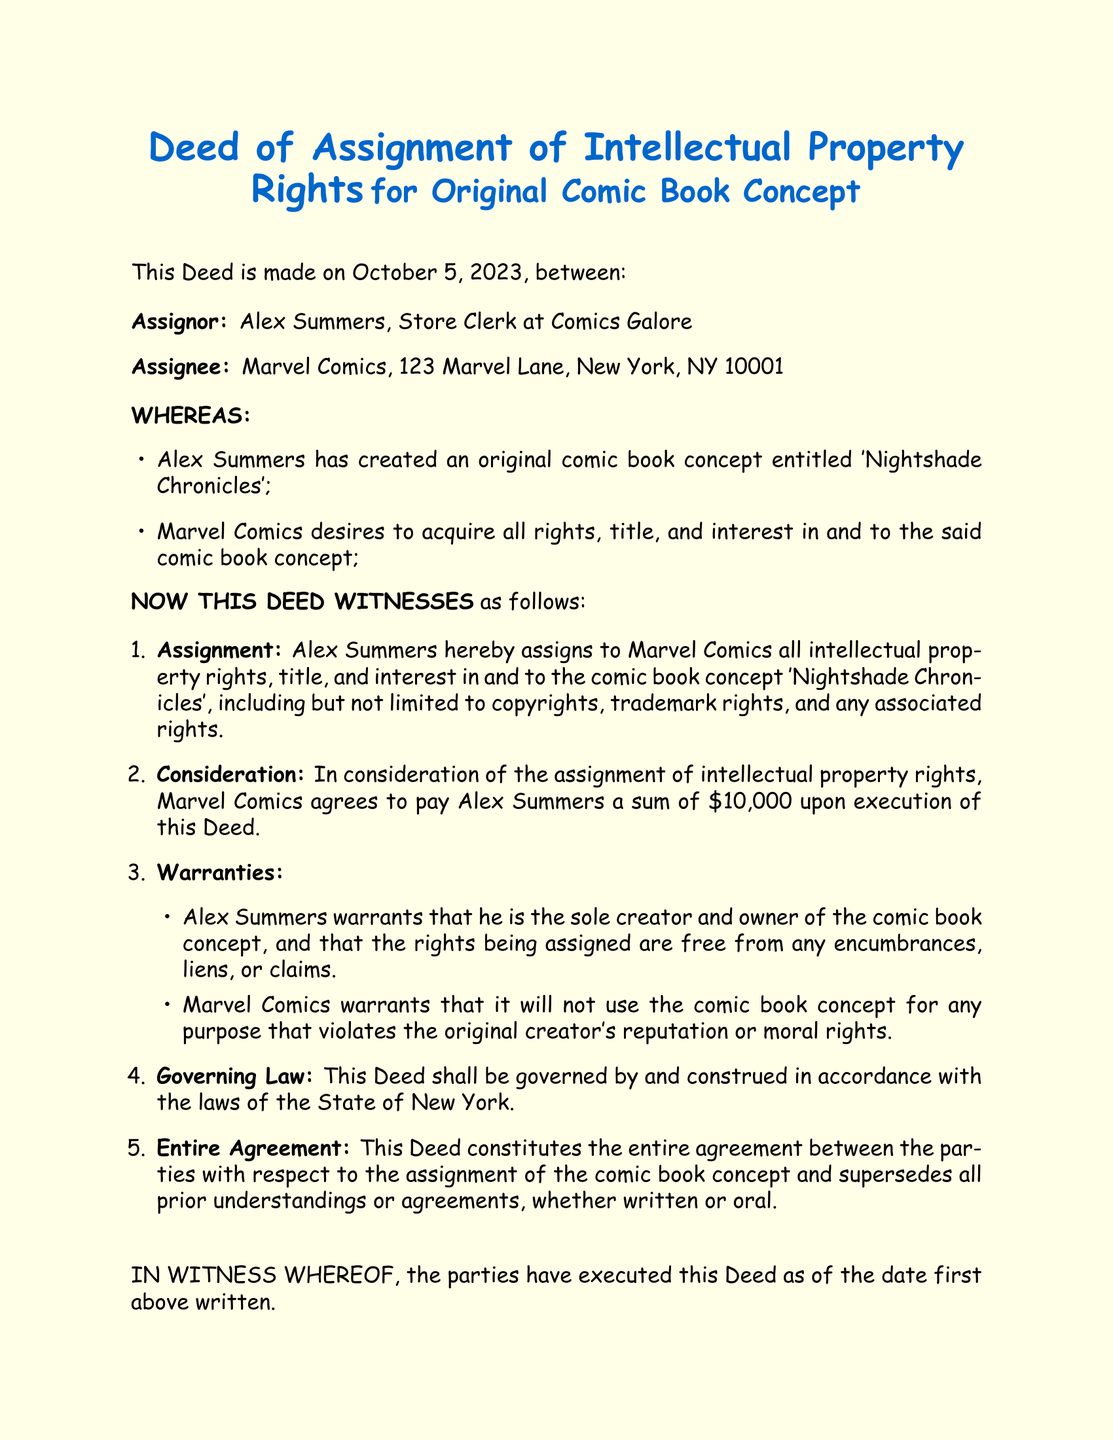What is the name of the original comic book concept? The document states that the original comic book concept is titled 'Nightshade Chronicles'.
Answer: 'Nightshade Chronicles' Who is the Assignor in the deed? The Assignor is identified as Alex Summers, Store Clerk at Comics Galore.
Answer: Alex Summers What is the amount agreed upon as consideration for the assignment? The consideration amount specified in the document is $10,000.
Answer: $10,000 What date was the deed executed? The deed was executed on October 5, 2023.
Answer: October 5, 2023 What warranties does Alex Summers provide? The warranties include that Alex Summers is the sole creator and owner of the comic book concept and that the rights are free from any encumbrances.
Answer: Sole creator and owner; free from encumbrances Under which state law is the deed governed? The deed specifies that it is governed by the laws of the State of New York.
Answer: State of New York What type of rights is assigned to Marvel Comics? The deed indicates that all intellectual property rights, title, and interest in the comic book concept are assigned.
Answer: Intellectual property rights What is the full name of the assignee? The full name of the Assignee as listed in the document is Jane Doe, CEO of Marvel Comics.
Answer: Jane Doe, CEO of Marvel Comics What type of document is this? This document is a Deed of Assignment of Intellectual Property Rights.
Answer: Deed of Assignment of Intellectual Property Rights 